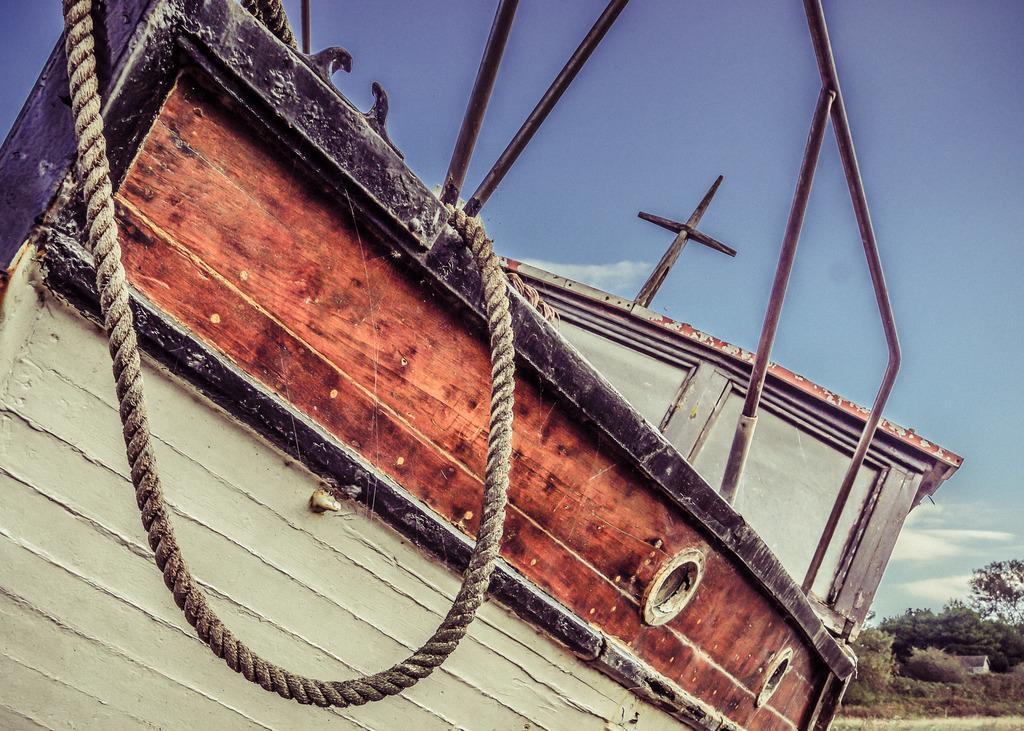Describe this image in one or two sentences. In this picture we can see a boat, few metal rods and a rope, in the background we can find few trees and clouds. 